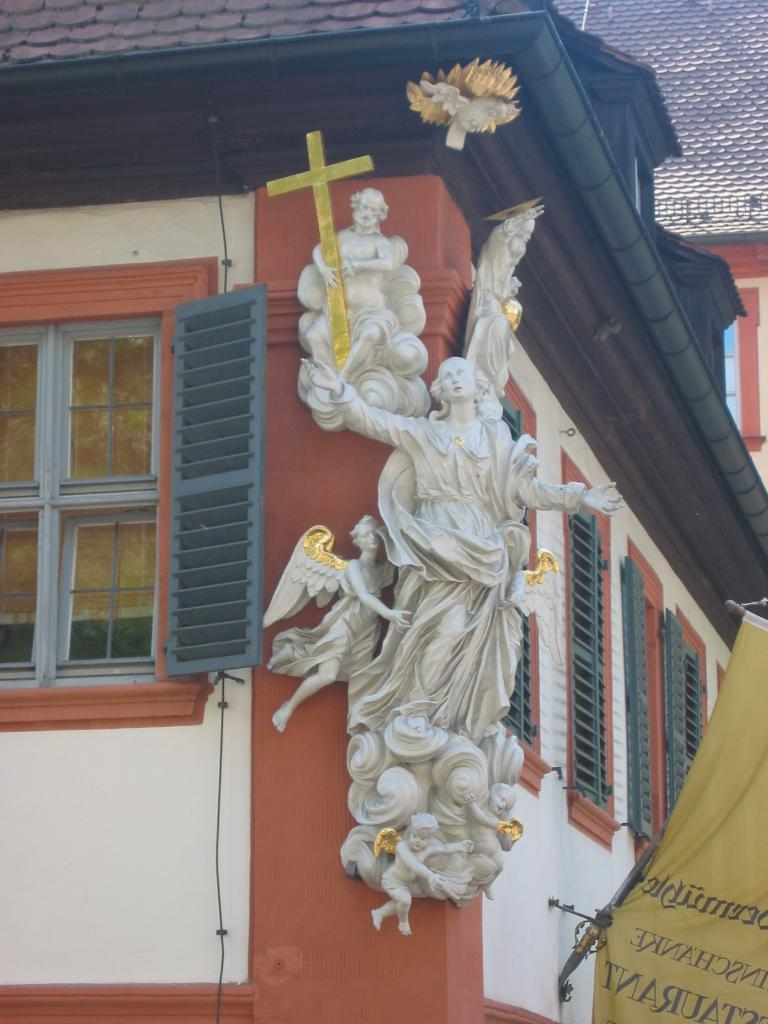What type of structure is visible in the image? There is a building in the image. What features can be observed on the building? The building has windows and sculptures. What is located on the right side of the image? There is a banner on the right side of the image. What type of game is being played in the image? There is no game being played in the image; it features a building with windows, sculptures, and a banner. 